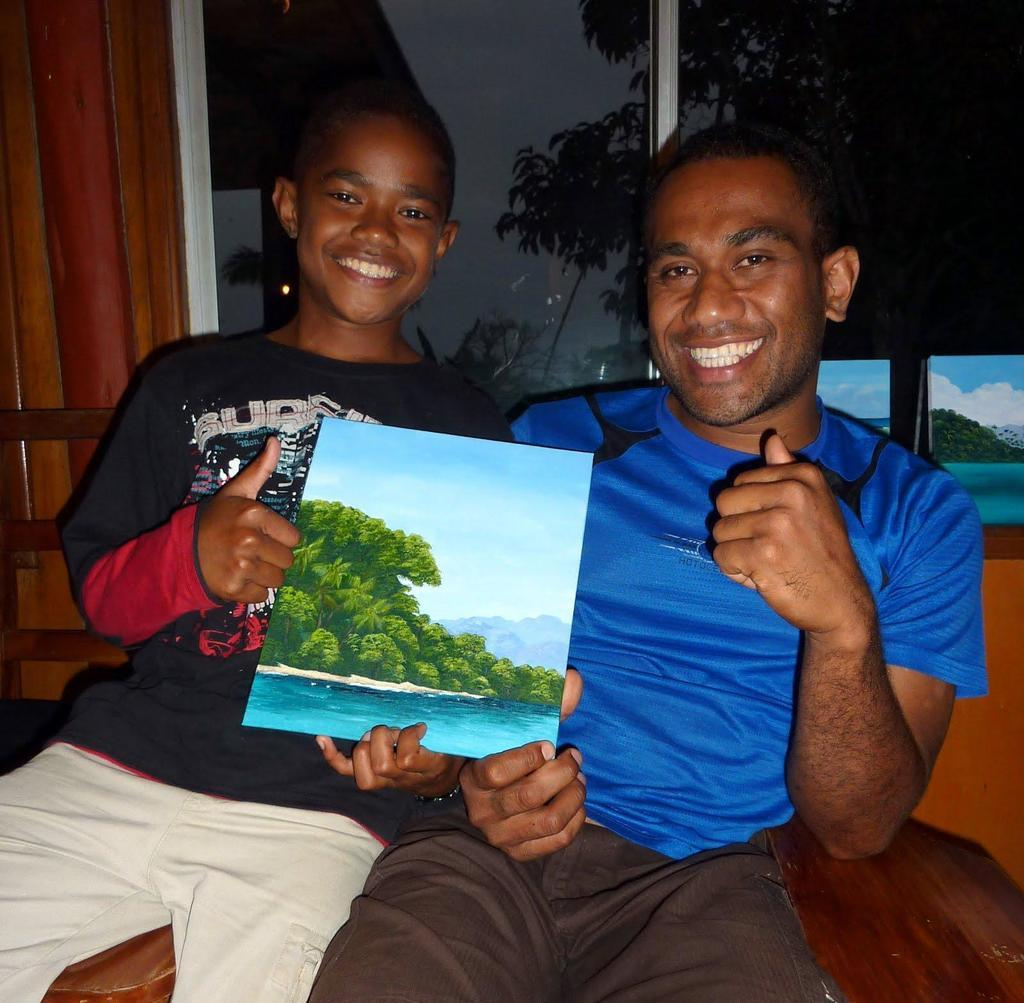Who is present in the image? There is a man and a kid in the image. What are the expressions on their faces? Both the man and the kid are smiling in the image. What are they holding together? They are holding a poster in the image. What type of gate can be seen in the image? There is no gate present in the image. What print is visible on the poster they are holding? The content or print on the poster is not mentioned in the provided facts, so it cannot be determined from the image. 